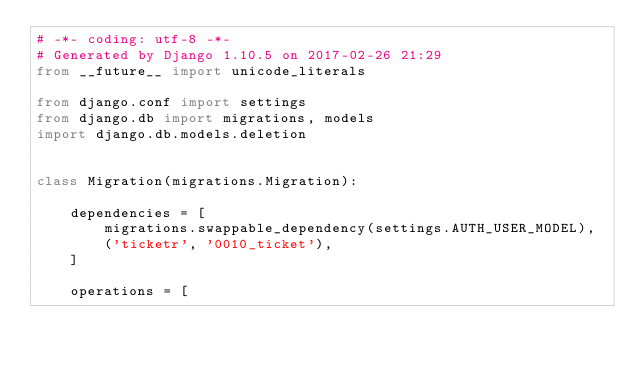Convert code to text. <code><loc_0><loc_0><loc_500><loc_500><_Python_># -*- coding: utf-8 -*-
# Generated by Django 1.10.5 on 2017-02-26 21:29
from __future__ import unicode_literals

from django.conf import settings
from django.db import migrations, models
import django.db.models.deletion


class Migration(migrations.Migration):

    dependencies = [
        migrations.swappable_dependency(settings.AUTH_USER_MODEL),
        ('ticketr', '0010_ticket'),
    ]

    operations = [</code> 